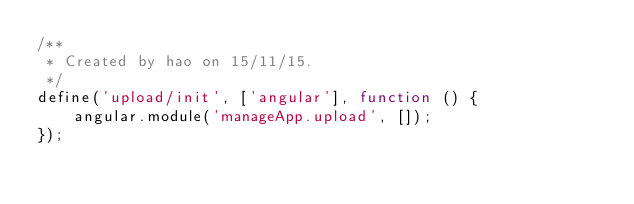<code> <loc_0><loc_0><loc_500><loc_500><_JavaScript_>/**
 * Created by hao on 15/11/15.
 */
define('upload/init', ['angular'], function () {
    angular.module('manageApp.upload', []);
});</code> 